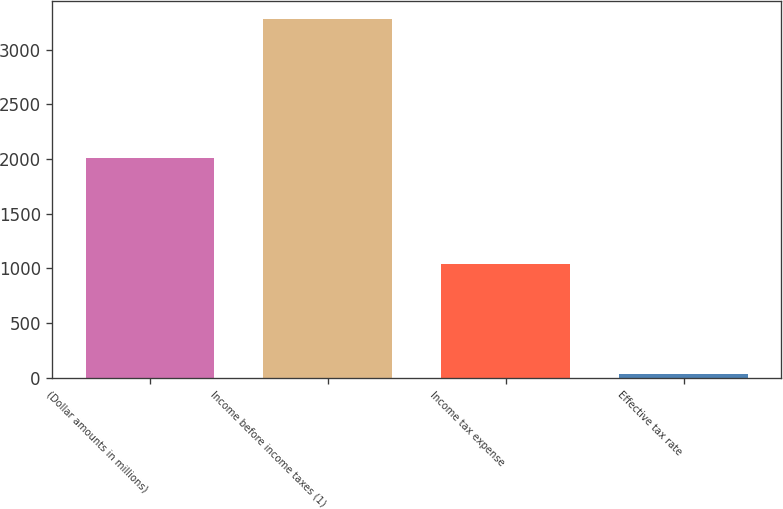Convert chart. <chart><loc_0><loc_0><loc_500><loc_500><bar_chart><fcel>(Dollar amounts in millions)<fcel>Income before income taxes (1)<fcel>Income tax expense<fcel>Effective tax rate<nl><fcel>2011<fcel>3279<fcel>1040<fcel>31.7<nl></chart> 